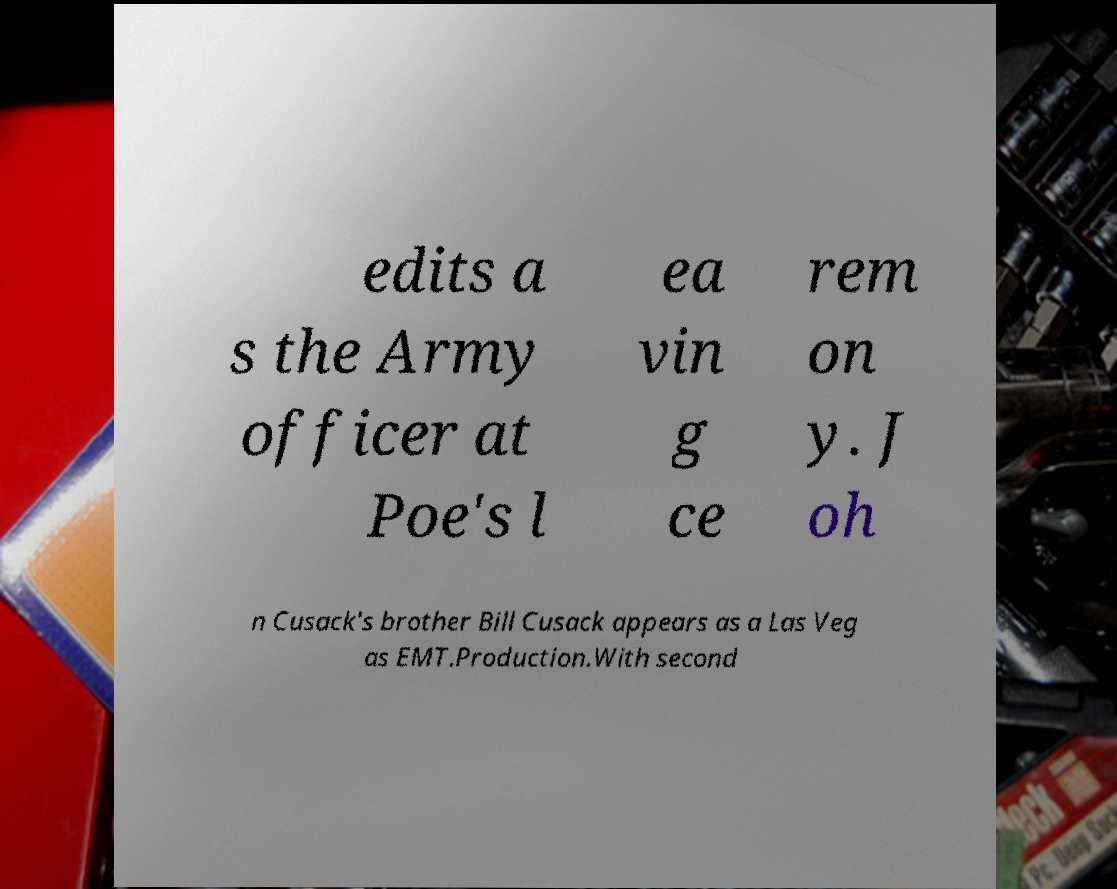There's text embedded in this image that I need extracted. Can you transcribe it verbatim? edits a s the Army officer at Poe's l ea vin g ce rem on y. J oh n Cusack's brother Bill Cusack appears as a Las Veg as EMT.Production.With second 